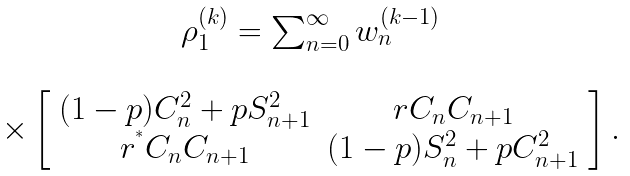<formula> <loc_0><loc_0><loc_500><loc_500>\begin{array} { c } \rho _ { 1 } ^ { ( k ) } = \sum _ { n = 0 } ^ { \infty } w _ { n } ^ { ( k - 1 ) } \\ \\ \times \left [ \begin{array} { c c } ( 1 - p ) C _ { n } ^ { 2 } + p S _ { n + 1 } ^ { 2 } & r C _ { n } C _ { n + 1 } \\ r ^ { ^ { * } } C _ { n } C _ { n + 1 } & ( 1 - p ) S _ { n } ^ { 2 } + p C _ { n + 1 } ^ { 2 } \end{array} \right ] . \end{array}</formula> 